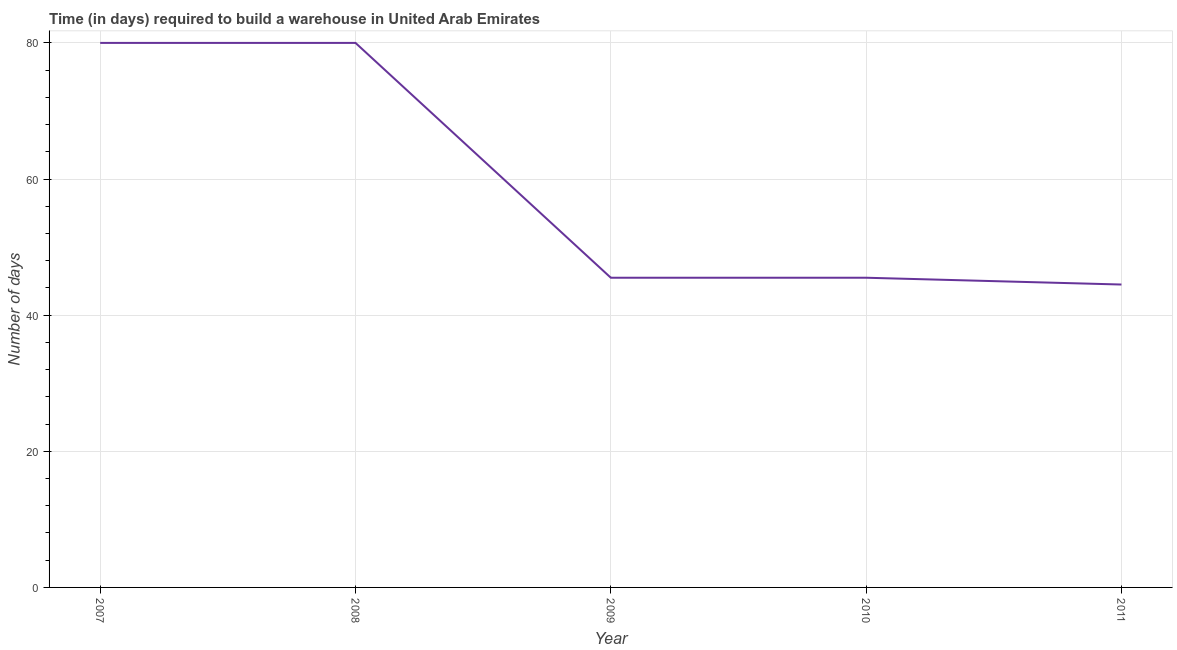What is the time required to build a warehouse in 2009?
Give a very brief answer. 45.5. Across all years, what is the minimum time required to build a warehouse?
Make the answer very short. 44.5. What is the sum of the time required to build a warehouse?
Make the answer very short. 295.5. What is the difference between the time required to build a warehouse in 2008 and 2010?
Your response must be concise. 34.5. What is the average time required to build a warehouse per year?
Offer a very short reply. 59.1. What is the median time required to build a warehouse?
Ensure brevity in your answer.  45.5. In how many years, is the time required to build a warehouse greater than 12 days?
Provide a short and direct response. 5. Do a majority of the years between 2009 and 2007 (inclusive) have time required to build a warehouse greater than 12 days?
Provide a succinct answer. No. What is the ratio of the time required to build a warehouse in 2008 to that in 2011?
Ensure brevity in your answer.  1.8. Is the difference between the time required to build a warehouse in 2008 and 2009 greater than the difference between any two years?
Provide a short and direct response. No. What is the difference between the highest and the second highest time required to build a warehouse?
Give a very brief answer. 0. What is the difference between the highest and the lowest time required to build a warehouse?
Your answer should be compact. 35.5. Does the time required to build a warehouse monotonically increase over the years?
Provide a succinct answer. No. How many lines are there?
Your response must be concise. 1. How many years are there in the graph?
Make the answer very short. 5. Does the graph contain grids?
Your answer should be compact. Yes. What is the title of the graph?
Offer a terse response. Time (in days) required to build a warehouse in United Arab Emirates. What is the label or title of the X-axis?
Offer a very short reply. Year. What is the label or title of the Y-axis?
Provide a succinct answer. Number of days. What is the Number of days of 2008?
Make the answer very short. 80. What is the Number of days in 2009?
Offer a terse response. 45.5. What is the Number of days of 2010?
Your answer should be very brief. 45.5. What is the Number of days of 2011?
Ensure brevity in your answer.  44.5. What is the difference between the Number of days in 2007 and 2009?
Provide a succinct answer. 34.5. What is the difference between the Number of days in 2007 and 2010?
Offer a very short reply. 34.5. What is the difference between the Number of days in 2007 and 2011?
Your response must be concise. 35.5. What is the difference between the Number of days in 2008 and 2009?
Provide a short and direct response. 34.5. What is the difference between the Number of days in 2008 and 2010?
Your answer should be compact. 34.5. What is the difference between the Number of days in 2008 and 2011?
Keep it short and to the point. 35.5. What is the difference between the Number of days in 2010 and 2011?
Your response must be concise. 1. What is the ratio of the Number of days in 2007 to that in 2008?
Your answer should be very brief. 1. What is the ratio of the Number of days in 2007 to that in 2009?
Offer a terse response. 1.76. What is the ratio of the Number of days in 2007 to that in 2010?
Provide a succinct answer. 1.76. What is the ratio of the Number of days in 2007 to that in 2011?
Offer a terse response. 1.8. What is the ratio of the Number of days in 2008 to that in 2009?
Your answer should be compact. 1.76. What is the ratio of the Number of days in 2008 to that in 2010?
Your answer should be compact. 1.76. What is the ratio of the Number of days in 2008 to that in 2011?
Your answer should be compact. 1.8. 